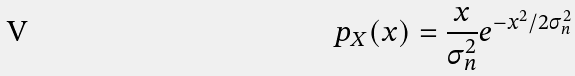Convert formula to latex. <formula><loc_0><loc_0><loc_500><loc_500>p _ { X } ( x ) = \frac { x } { \sigma _ { n } ^ { 2 } } e ^ { - x ^ { 2 } / 2 \sigma _ { n } ^ { 2 } }</formula> 